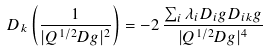Convert formula to latex. <formula><loc_0><loc_0><loc_500><loc_500>D _ { k } \left ( \frac { 1 } { | Q ^ { 1 / 2 } D g | ^ { 2 } } \right ) = - 2 \, \frac { \sum _ { i } \lambda _ { i } D _ { i } g D _ { i k } g } { | Q ^ { 1 / 2 } D g | ^ { 4 } }</formula> 